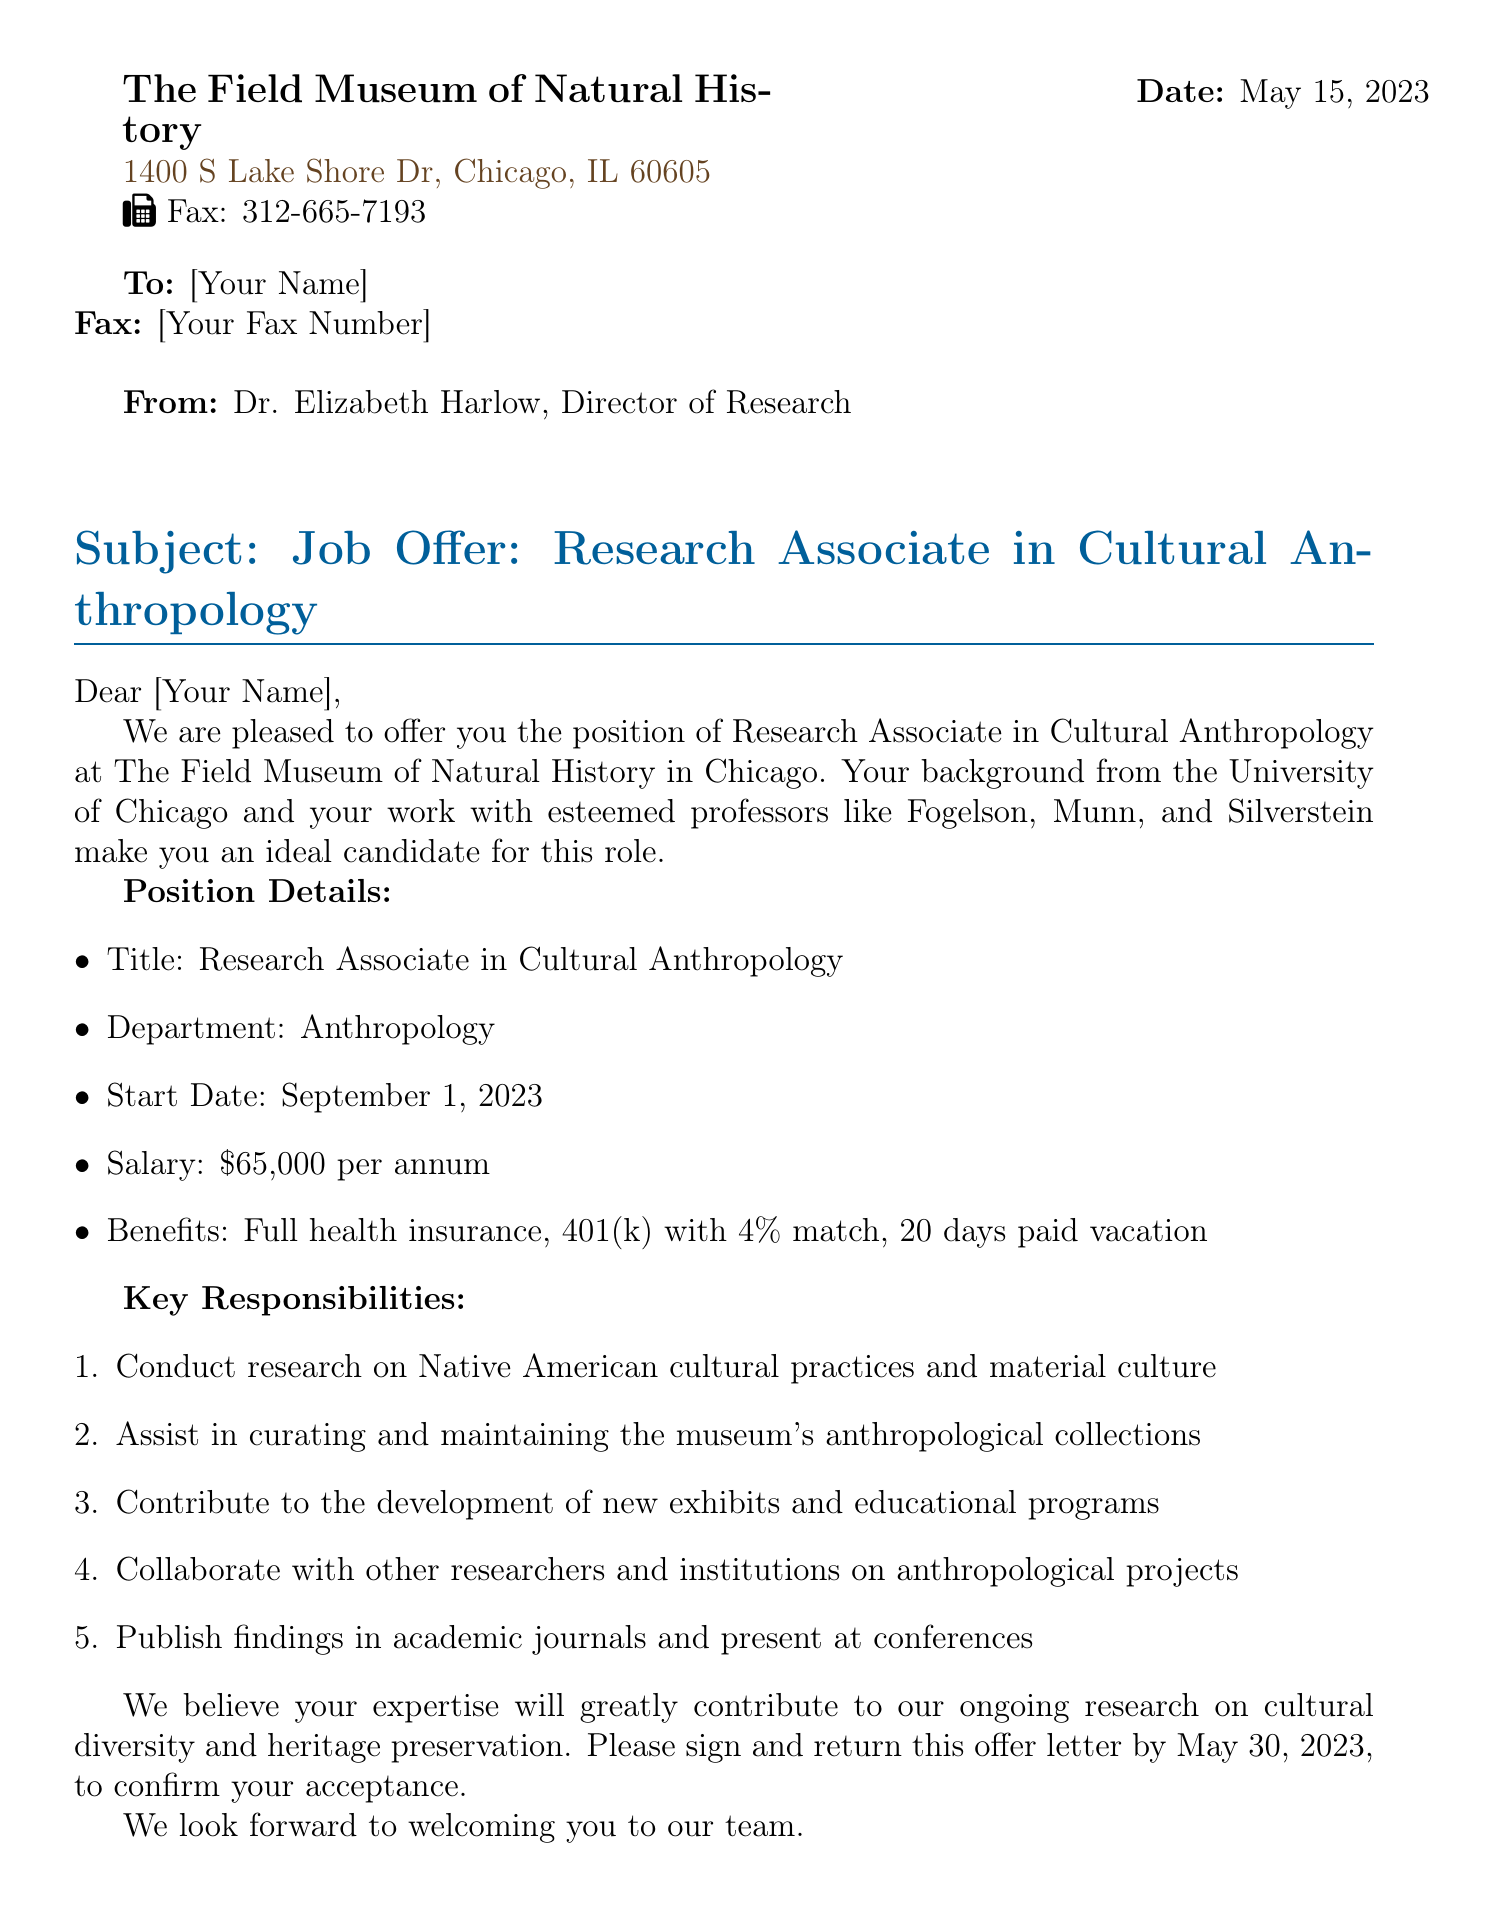What is the position title? The position title is stated in the document as "Research Associate in Cultural Anthropology."
Answer: Research Associate in Cultural Anthropology Who is the director of research? The document identifies Dr. Elizabeth Harlow as the Director of Research.
Answer: Dr. Elizabeth Harlow What is the salary for this position? The salary is listed in the document as $65,000 per annum.
Answer: $65,000 per annum When is the start date for the position? The start date is specified in the document as September 1, 2023.
Answer: September 1, 2023 What are the benefits included? The document mentions full health insurance, 401(k) with 4% match, and 20 days paid vacation as benefits.
Answer: Full health insurance, 401(k) with 4% match, 20 days paid vacation What is one key responsibility of the research associate? The document outlines "Conduct research on Native American cultural practices and material culture" as one of the key responsibilities.
Answer: Conduct research on Native American cultural practices and material culture What is the deadline to sign and return the offer letter? The document states that the offer letter must be signed and returned by May 30, 2023.
Answer: May 30, 2023 What is the fax number provided in the document? The document lists the fax number as 312-665-7193.
Answer: 312-665-7193 What address is mentioned for The Field Museum? The address provided in the document is "1400 S Lake Shore Dr, Chicago, IL 60605."
Answer: 1400 S Lake Shore Dr, Chicago, IL 60605 